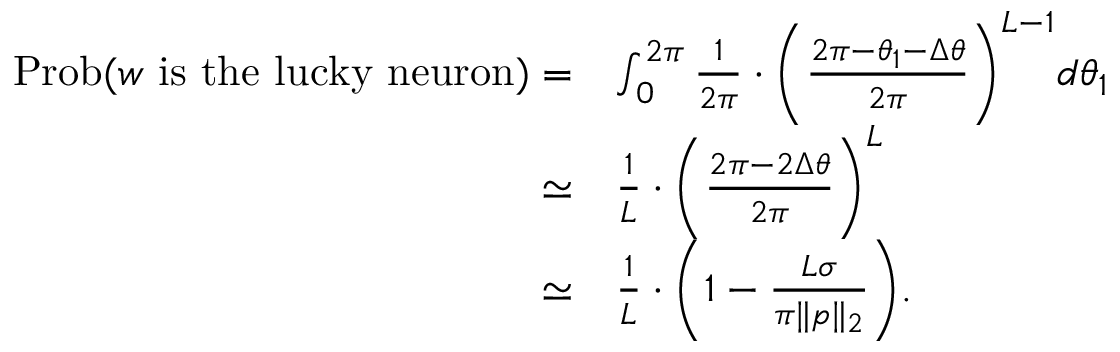<formula> <loc_0><loc_0><loc_500><loc_500>\begin{array} { r l } { P r o b ( { \boldsymbol w } i s t h e l u c k y n e u r o n ) = } & { \int _ { 0 } ^ { 2 \pi } \frac { 1 } { 2 \pi } \cdot \left ( \frac { 2 \pi - \theta _ { 1 } - \Delta \theta } { 2 \pi } \right ) ^ { L - 1 } d \theta _ { 1 } } \\ { \simeq } & { \frac { 1 } { L } \cdot \left ( \frac { 2 \pi - 2 \Delta \theta } { 2 \pi } \right ) ^ { L } } \\ { \simeq } & { \frac { 1 } { L } \cdot \left ( 1 - \frac { L \sigma } { \pi \| { \boldsymbol p } \| _ { 2 } } \right ) . } \end{array}</formula> 